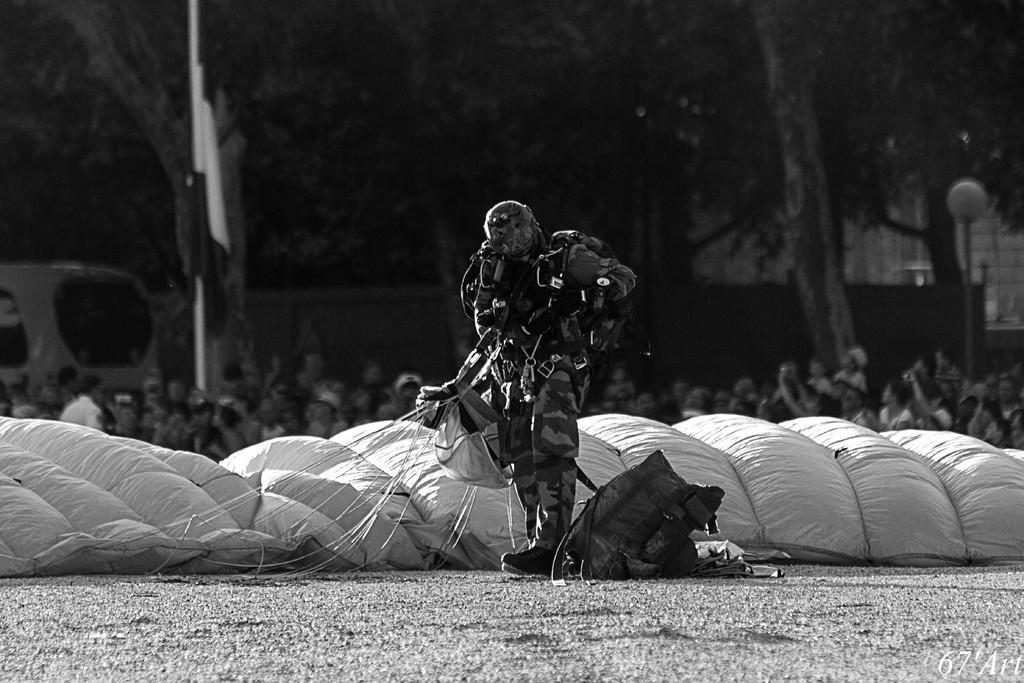Please provide a concise description of this image. It is a black and white image. In this image we can see a man standing. We can also see the bags, parachute. In the background we can see the light pole, flag, trees, vehicle and also the people. At the bottom we can see the land. 